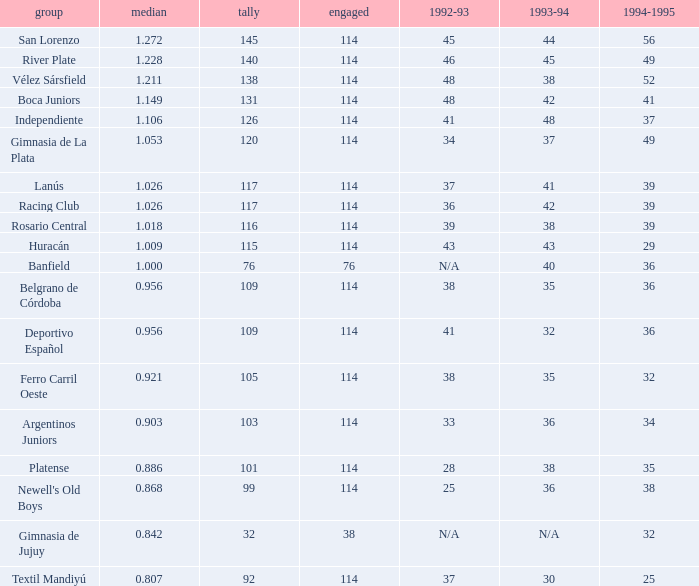Name the most played 114.0. Would you mind parsing the complete table? {'header': ['group', 'median', 'tally', 'engaged', '1992-93', '1993-94', '1994-1995'], 'rows': [['San Lorenzo', '1.272', '145', '114', '45', '44', '56'], ['River Plate', '1.228', '140', '114', '46', '45', '49'], ['Vélez Sársfield', '1.211', '138', '114', '48', '38', '52'], ['Boca Juniors', '1.149', '131', '114', '48', '42', '41'], ['Independiente', '1.106', '126', '114', '41', '48', '37'], ['Gimnasia de La Plata', '1.053', '120', '114', '34', '37', '49'], ['Lanús', '1.026', '117', '114', '37', '41', '39'], ['Racing Club', '1.026', '117', '114', '36', '42', '39'], ['Rosario Central', '1.018', '116', '114', '39', '38', '39'], ['Huracán', '1.009', '115', '114', '43', '43', '29'], ['Banfield', '1.000', '76', '76', 'N/A', '40', '36'], ['Belgrano de Córdoba', '0.956', '109', '114', '38', '35', '36'], ['Deportivo Español', '0.956', '109', '114', '41', '32', '36'], ['Ferro Carril Oeste', '0.921', '105', '114', '38', '35', '32'], ['Argentinos Juniors', '0.903', '103', '114', '33', '36', '34'], ['Platense', '0.886', '101', '114', '28', '38', '35'], ["Newell's Old Boys", '0.868', '99', '114', '25', '36', '38'], ['Gimnasia de Jujuy', '0.842', '32', '38', 'N/A', 'N/A', '32'], ['Textil Mandiyú', '0.807', '92', '114', '37', '30', '25']]} 